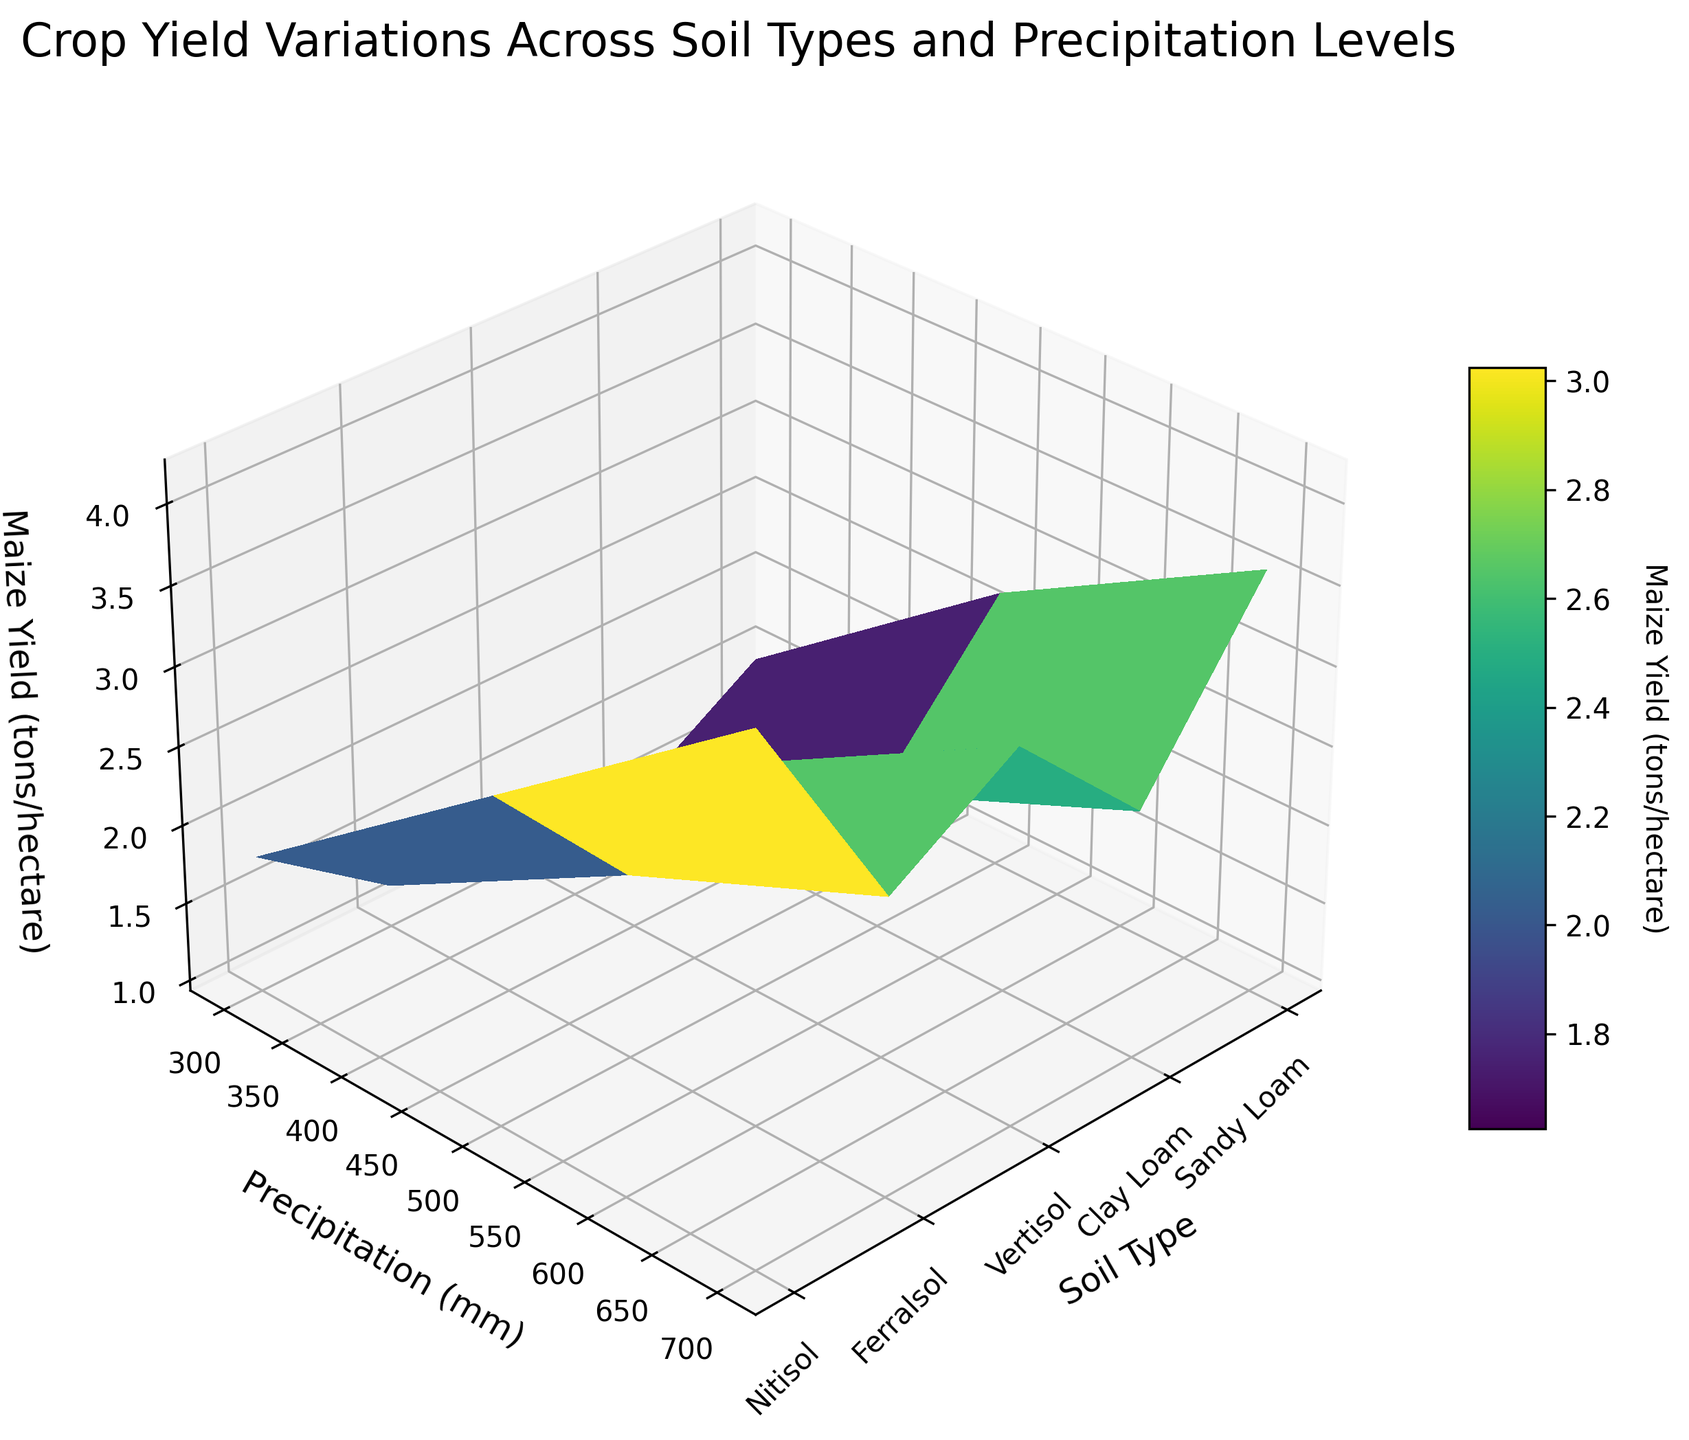Which soil type has the lowest maize yield at 700 mm precipitation? Look at the subplot corresponding to 700 mm precipitation and compare the maize yield values. Ferralsol has the lowest yield.
Answer: Ferralsol How does maize yield change in Sandy Loam soil type as precipitation increases from 300 mm to 700 mm? Observe the Z-axis values for Sandy Loam at 300 mm, 500 mm, and 700 mm precipitation. The yields are 1.2, 2.1, and 2.8, respectively, indicating a steady increase.
Answer: It increases What is the average maize yield across all soil types at 500 mm precipitation? Add the maize yields for all soil types at 500 mm (2.1, 2.7, 3.0, 1.8, 2.4) and divide by the number of soil types (5). (2.1 + 2.7 + 3.0 + 1.8 + 2.4) / 5 = 12 / 5 = 2.4
Answer: 2.4 tons/hectare Which soil type had the highest yield increase when precipitation changed from 300 mm to 700 mm? Find the difference in maize yields at 300 mm and 700 mm precipitation for each soil type, and identify the one with the highest increase. Increases: Sandy Loam (1.2 to 2.8 = 1.6), Clay Loam (1.5 to 3.6 = 2.1), Vertisol (1.8 to 4.2 = 2.4), Ferralsol (1.0 to 2.5 = 1.5), Nitisol (1.3 to 3.3 = 2.0). Vertisol has the highest increase.
Answer: Vertisol What is the range of maize yield values observed for Vertisol soil type? Identify the minimum and maximum maize yield values for Vertisol soil type (1.8 and 4.2, respectively), and calculate the range (4.2 - 1.8 = 2.4).
Answer: 2.4 tons/hectare Compare the maize yield for Clay Loam and Nitisol at 700 mm precipitation. Which is higher and by how much? Note the maize yields at 700 mm precipitation for Clay Loam (3.6) and Nitisol (3.3). The difference (3.6 - 3.3) is 0.3.
Answer: Clay Loam, by 0.3 tons/hectare At 300 mm of precipitation, which soil type achieves a maize yield around 1.3 tons/hectare? Check the yields of all soil types at 300 mm; Nitisol yields 1.3 tons/hectare at this precipitation level.
Answer: Nitisol Does the maize yield for Ferralsol ever exceed 3 tons/hectare? Review the maize yield values for Ferralsol at all precipitation levels: 1.0, 1.8, and 2.5. It never exceeds 3 tons/hectare.
Answer: No 